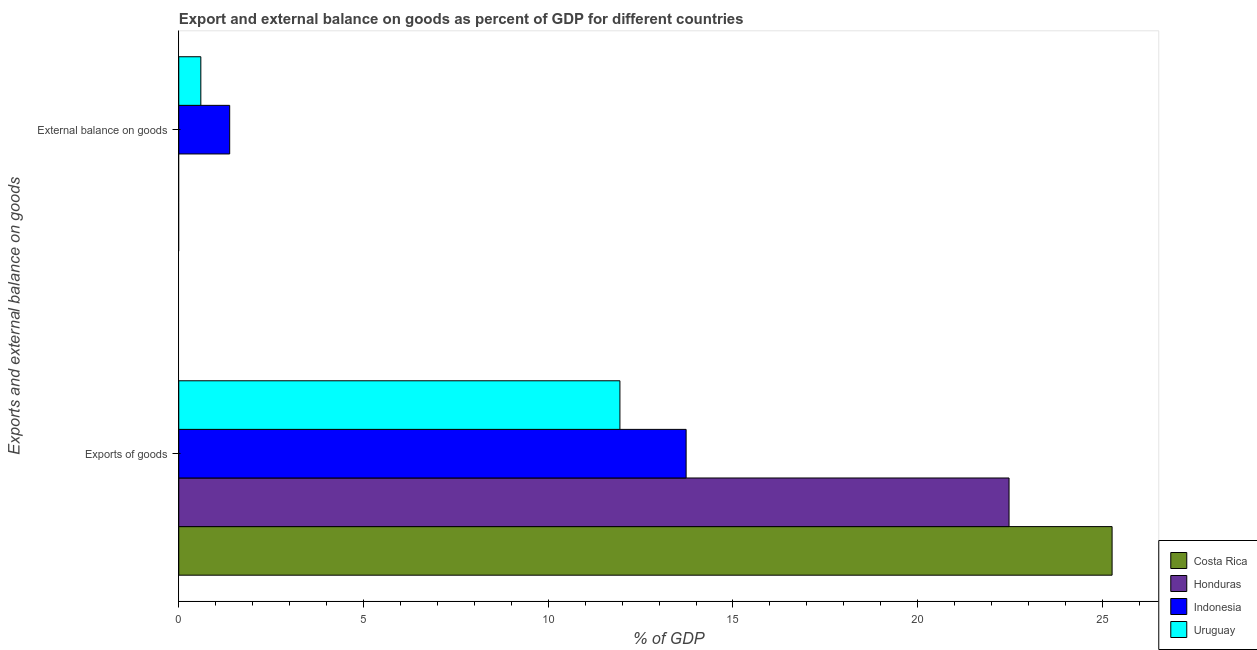How many different coloured bars are there?
Your answer should be very brief. 4. Are the number of bars per tick equal to the number of legend labels?
Provide a short and direct response. No. Are the number of bars on each tick of the Y-axis equal?
Offer a terse response. No. What is the label of the 1st group of bars from the top?
Keep it short and to the point. External balance on goods. What is the export of goods as percentage of gdp in Honduras?
Make the answer very short. 22.47. Across all countries, what is the maximum external balance on goods as percentage of gdp?
Provide a short and direct response. 1.38. Across all countries, what is the minimum export of goods as percentage of gdp?
Make the answer very short. 11.94. In which country was the external balance on goods as percentage of gdp maximum?
Your answer should be compact. Indonesia. What is the total external balance on goods as percentage of gdp in the graph?
Offer a terse response. 1.98. What is the difference between the export of goods as percentage of gdp in Costa Rica and that in Honduras?
Keep it short and to the point. 2.79. What is the difference between the export of goods as percentage of gdp in Indonesia and the external balance on goods as percentage of gdp in Uruguay?
Provide a short and direct response. 13.14. What is the average external balance on goods as percentage of gdp per country?
Give a very brief answer. 0.49. What is the difference between the external balance on goods as percentage of gdp and export of goods as percentage of gdp in Uruguay?
Provide a succinct answer. -11.34. What is the ratio of the export of goods as percentage of gdp in Uruguay to that in Honduras?
Provide a short and direct response. 0.53. Is the export of goods as percentage of gdp in Costa Rica less than that in Indonesia?
Your answer should be very brief. No. In how many countries, is the export of goods as percentage of gdp greater than the average export of goods as percentage of gdp taken over all countries?
Provide a succinct answer. 2. Are all the bars in the graph horizontal?
Keep it short and to the point. Yes. Does the graph contain any zero values?
Your answer should be compact. Yes. Does the graph contain grids?
Give a very brief answer. No. How many legend labels are there?
Make the answer very short. 4. How are the legend labels stacked?
Your answer should be very brief. Vertical. What is the title of the graph?
Give a very brief answer. Export and external balance on goods as percent of GDP for different countries. What is the label or title of the X-axis?
Your answer should be compact. % of GDP. What is the label or title of the Y-axis?
Ensure brevity in your answer.  Exports and external balance on goods. What is the % of GDP in Costa Rica in Exports of goods?
Give a very brief answer. 25.26. What is the % of GDP in Honduras in Exports of goods?
Give a very brief answer. 22.47. What is the % of GDP of Indonesia in Exports of goods?
Make the answer very short. 13.73. What is the % of GDP of Uruguay in Exports of goods?
Make the answer very short. 11.94. What is the % of GDP of Indonesia in External balance on goods?
Offer a very short reply. 1.38. What is the % of GDP in Uruguay in External balance on goods?
Your answer should be very brief. 0.6. Across all Exports and external balance on goods, what is the maximum % of GDP of Costa Rica?
Your answer should be very brief. 25.26. Across all Exports and external balance on goods, what is the maximum % of GDP in Honduras?
Your answer should be compact. 22.47. Across all Exports and external balance on goods, what is the maximum % of GDP in Indonesia?
Provide a short and direct response. 13.73. Across all Exports and external balance on goods, what is the maximum % of GDP of Uruguay?
Offer a terse response. 11.94. Across all Exports and external balance on goods, what is the minimum % of GDP in Honduras?
Provide a short and direct response. 0. Across all Exports and external balance on goods, what is the minimum % of GDP of Indonesia?
Provide a short and direct response. 1.38. Across all Exports and external balance on goods, what is the minimum % of GDP in Uruguay?
Give a very brief answer. 0.6. What is the total % of GDP in Costa Rica in the graph?
Provide a succinct answer. 25.26. What is the total % of GDP of Honduras in the graph?
Keep it short and to the point. 22.47. What is the total % of GDP in Indonesia in the graph?
Provide a short and direct response. 15.11. What is the total % of GDP of Uruguay in the graph?
Offer a terse response. 12.54. What is the difference between the % of GDP of Indonesia in Exports of goods and that in External balance on goods?
Offer a terse response. 12.35. What is the difference between the % of GDP of Uruguay in Exports of goods and that in External balance on goods?
Offer a very short reply. 11.34. What is the difference between the % of GDP of Costa Rica in Exports of goods and the % of GDP of Indonesia in External balance on goods?
Offer a very short reply. 23.88. What is the difference between the % of GDP of Costa Rica in Exports of goods and the % of GDP of Uruguay in External balance on goods?
Your answer should be compact. 24.66. What is the difference between the % of GDP in Honduras in Exports of goods and the % of GDP in Indonesia in External balance on goods?
Your answer should be very brief. 21.09. What is the difference between the % of GDP of Honduras in Exports of goods and the % of GDP of Uruguay in External balance on goods?
Provide a succinct answer. 21.88. What is the difference between the % of GDP of Indonesia in Exports of goods and the % of GDP of Uruguay in External balance on goods?
Provide a succinct answer. 13.14. What is the average % of GDP of Costa Rica per Exports and external balance on goods?
Your response must be concise. 12.63. What is the average % of GDP in Honduras per Exports and external balance on goods?
Your answer should be very brief. 11.24. What is the average % of GDP in Indonesia per Exports and external balance on goods?
Your answer should be very brief. 7.56. What is the average % of GDP in Uruguay per Exports and external balance on goods?
Ensure brevity in your answer.  6.27. What is the difference between the % of GDP in Costa Rica and % of GDP in Honduras in Exports of goods?
Your response must be concise. 2.79. What is the difference between the % of GDP in Costa Rica and % of GDP in Indonesia in Exports of goods?
Offer a very short reply. 11.53. What is the difference between the % of GDP of Costa Rica and % of GDP of Uruguay in Exports of goods?
Give a very brief answer. 13.32. What is the difference between the % of GDP of Honduras and % of GDP of Indonesia in Exports of goods?
Keep it short and to the point. 8.74. What is the difference between the % of GDP of Honduras and % of GDP of Uruguay in Exports of goods?
Provide a short and direct response. 10.53. What is the difference between the % of GDP of Indonesia and % of GDP of Uruguay in Exports of goods?
Provide a succinct answer. 1.79. What is the difference between the % of GDP of Indonesia and % of GDP of Uruguay in External balance on goods?
Give a very brief answer. 0.78. What is the ratio of the % of GDP of Indonesia in Exports of goods to that in External balance on goods?
Your response must be concise. 9.96. What is the ratio of the % of GDP in Uruguay in Exports of goods to that in External balance on goods?
Provide a short and direct response. 20. What is the difference between the highest and the second highest % of GDP in Indonesia?
Ensure brevity in your answer.  12.35. What is the difference between the highest and the second highest % of GDP in Uruguay?
Ensure brevity in your answer.  11.34. What is the difference between the highest and the lowest % of GDP of Costa Rica?
Make the answer very short. 25.26. What is the difference between the highest and the lowest % of GDP of Honduras?
Keep it short and to the point. 22.47. What is the difference between the highest and the lowest % of GDP of Indonesia?
Offer a terse response. 12.35. What is the difference between the highest and the lowest % of GDP in Uruguay?
Your response must be concise. 11.34. 